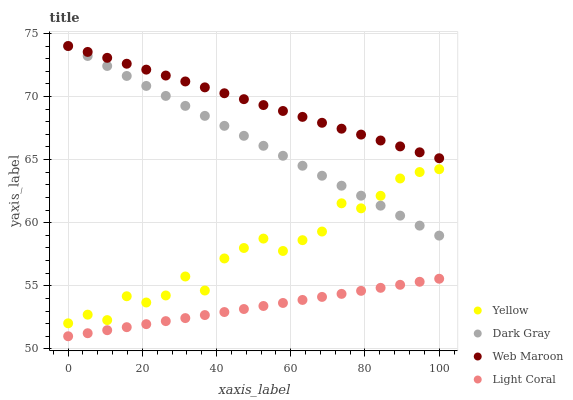Does Light Coral have the minimum area under the curve?
Answer yes or no. Yes. Does Web Maroon have the maximum area under the curve?
Answer yes or no. Yes. Does Web Maroon have the minimum area under the curve?
Answer yes or no. No. Does Light Coral have the maximum area under the curve?
Answer yes or no. No. Is Light Coral the smoothest?
Answer yes or no. Yes. Is Yellow the roughest?
Answer yes or no. Yes. Is Web Maroon the smoothest?
Answer yes or no. No. Is Web Maroon the roughest?
Answer yes or no. No. Does Light Coral have the lowest value?
Answer yes or no. Yes. Does Web Maroon have the lowest value?
Answer yes or no. No. Does Web Maroon have the highest value?
Answer yes or no. Yes. Does Light Coral have the highest value?
Answer yes or no. No. Is Light Coral less than Dark Gray?
Answer yes or no. Yes. Is Yellow greater than Light Coral?
Answer yes or no. Yes. Does Dark Gray intersect Web Maroon?
Answer yes or no. Yes. Is Dark Gray less than Web Maroon?
Answer yes or no. No. Is Dark Gray greater than Web Maroon?
Answer yes or no. No. Does Light Coral intersect Dark Gray?
Answer yes or no. No. 